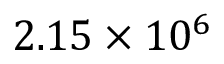<formula> <loc_0><loc_0><loc_500><loc_500>2 . 1 5 \times 1 0 ^ { 6 }</formula> 